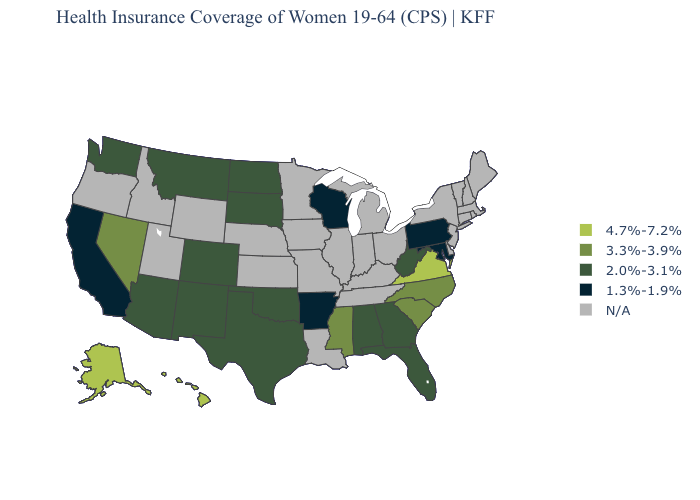What is the value of Texas?
Give a very brief answer. 2.0%-3.1%. Which states have the lowest value in the West?
Short answer required. California. Which states hav the highest value in the Northeast?
Keep it brief. Pennsylvania. Which states have the lowest value in the West?
Write a very short answer. California. Among the states that border California , does Arizona have the highest value?
Keep it brief. No. Which states have the lowest value in the USA?
Short answer required. Arkansas, California, Maryland, Pennsylvania, Wisconsin. Name the states that have a value in the range 2.0%-3.1%?
Keep it brief. Alabama, Arizona, Colorado, Florida, Georgia, Montana, New Mexico, North Dakota, Oklahoma, South Dakota, Texas, Washington, West Virginia. Among the states that border Arizona , which have the highest value?
Quick response, please. Nevada. Name the states that have a value in the range 2.0%-3.1%?
Keep it brief. Alabama, Arizona, Colorado, Florida, Georgia, Montana, New Mexico, North Dakota, Oklahoma, South Dakota, Texas, Washington, West Virginia. Name the states that have a value in the range 2.0%-3.1%?
Answer briefly. Alabama, Arizona, Colorado, Florida, Georgia, Montana, New Mexico, North Dakota, Oklahoma, South Dakota, Texas, Washington, West Virginia. What is the value of Indiana?
Answer briefly. N/A. What is the value of North Dakota?
Quick response, please. 2.0%-3.1%. What is the value of California?
Keep it brief. 1.3%-1.9%. Name the states that have a value in the range N/A?
Give a very brief answer. Connecticut, Delaware, Idaho, Illinois, Indiana, Iowa, Kansas, Kentucky, Louisiana, Maine, Massachusetts, Michigan, Minnesota, Missouri, Nebraska, New Hampshire, New Jersey, New York, Ohio, Oregon, Rhode Island, Tennessee, Utah, Vermont, Wyoming. What is the highest value in the USA?
Answer briefly. 4.7%-7.2%. 